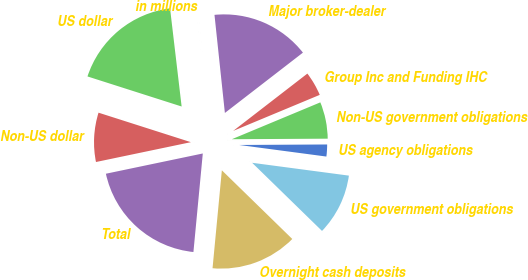Convert chart to OTSL. <chart><loc_0><loc_0><loc_500><loc_500><pie_chart><fcel>in millions<fcel>US dollar<fcel>Non-US dollar<fcel>Total<fcel>Overnight cash deposits<fcel>US government obligations<fcel>US agency obligations<fcel>Non-US government obligations<fcel>Group Inc and Funding IHC<fcel>Major broker-dealer<nl><fcel>0.19%<fcel>18.21%<fcel>8.2%<fcel>20.21%<fcel>14.21%<fcel>10.2%<fcel>2.19%<fcel>6.19%<fcel>4.19%<fcel>16.21%<nl></chart> 